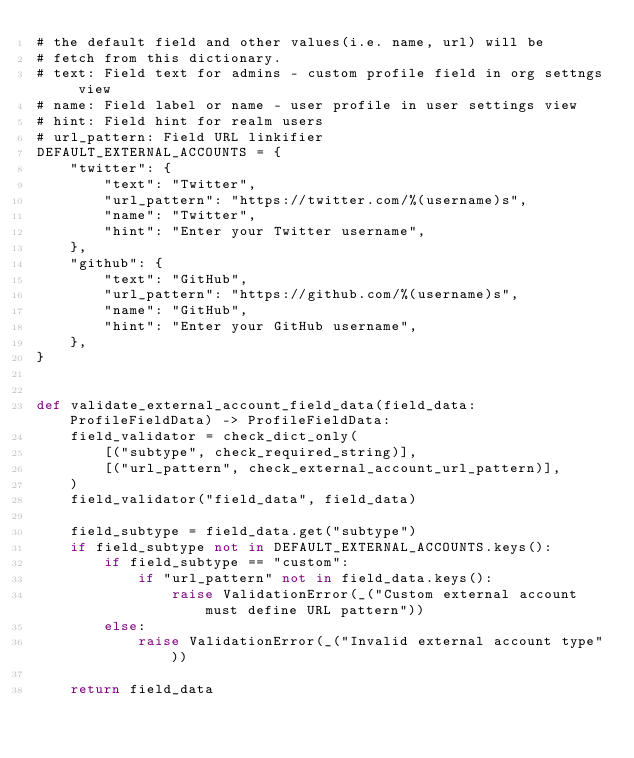Convert code to text. <code><loc_0><loc_0><loc_500><loc_500><_Python_># the default field and other values(i.e. name, url) will be
# fetch from this dictionary.
# text: Field text for admins - custom profile field in org settngs view
# name: Field label or name - user profile in user settings view
# hint: Field hint for realm users
# url_pattern: Field URL linkifier
DEFAULT_EXTERNAL_ACCOUNTS = {
    "twitter": {
        "text": "Twitter",
        "url_pattern": "https://twitter.com/%(username)s",
        "name": "Twitter",
        "hint": "Enter your Twitter username",
    },
    "github": {
        "text": "GitHub",
        "url_pattern": "https://github.com/%(username)s",
        "name": "GitHub",
        "hint": "Enter your GitHub username",
    },
}


def validate_external_account_field_data(field_data: ProfileFieldData) -> ProfileFieldData:
    field_validator = check_dict_only(
        [("subtype", check_required_string)],
        [("url_pattern", check_external_account_url_pattern)],
    )
    field_validator("field_data", field_data)

    field_subtype = field_data.get("subtype")
    if field_subtype not in DEFAULT_EXTERNAL_ACCOUNTS.keys():
        if field_subtype == "custom":
            if "url_pattern" not in field_data.keys():
                raise ValidationError(_("Custom external account must define URL pattern"))
        else:
            raise ValidationError(_("Invalid external account type"))

    return field_data
</code> 